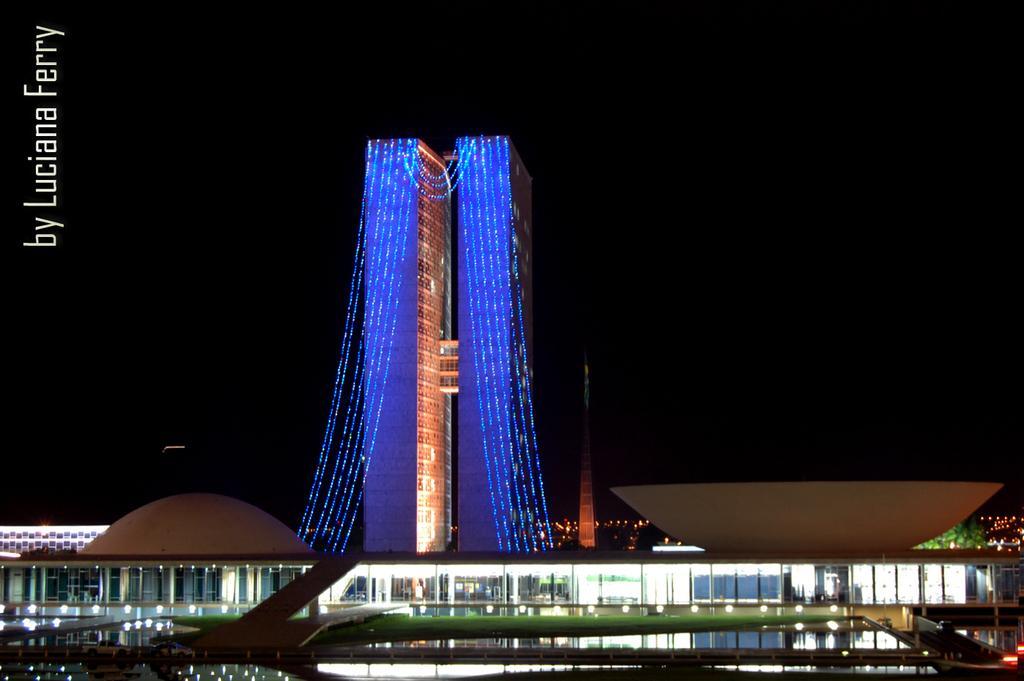Can you describe this image briefly? In this image I can see the water, few lights, few vehicles on the ground, a huge building and few blue colored lights to the building. I can see few trees, a tower and the dark sky in the background. 